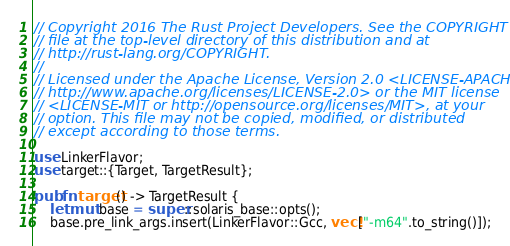Convert code to text. <code><loc_0><loc_0><loc_500><loc_500><_Rust_>// Copyright 2016 The Rust Project Developers. See the COPYRIGHT
// file at the top-level directory of this distribution and at
// http://rust-lang.org/COPYRIGHT.
//
// Licensed under the Apache License, Version 2.0 <LICENSE-APACHE or
// http://www.apache.org/licenses/LICENSE-2.0> or the MIT license
// <LICENSE-MIT or http://opensource.org/licenses/MIT>, at your
// option. This file may not be copied, modified, or distributed
// except according to those terms.

use LinkerFlavor;
use target::{Target, TargetResult};

pub fn target() -> TargetResult {
    let mut base = super::solaris_base::opts();
    base.pre_link_args.insert(LinkerFlavor::Gcc, vec!["-m64".to_string()]);</code> 